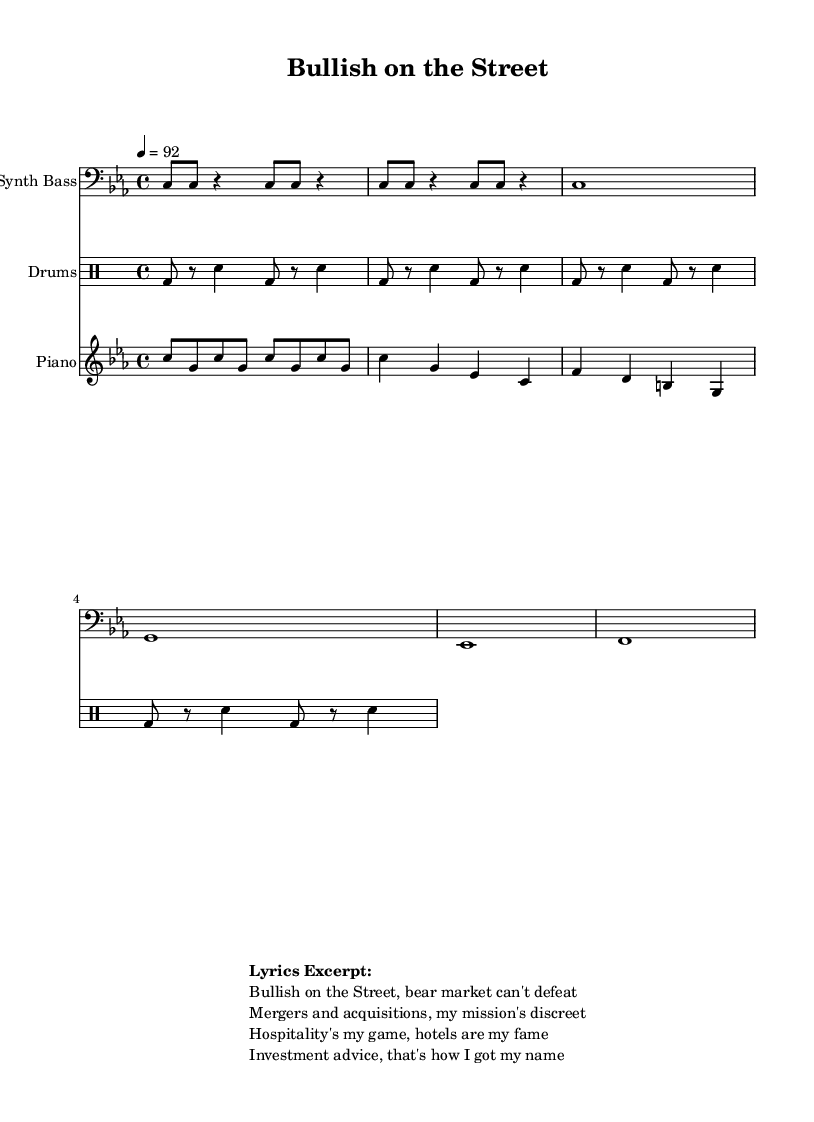What is the key signature of this music? The key signature is C minor, which has three flats: B flat, E flat, and A flat. This is indicated in the music sheet at the beginning of the staff.
Answer: C minor What is the time signature of this music? The time signature is 4/4, which means there are four beats in each measure and a quarter note receives one beat. This is displayed at the start of the score.
Answer: 4/4 What is the tempo of this piece? The tempo is set at 92 beats per minute, indicated by the tempo marking "4 = 92" at the beginning of the score. This tells performers how quickly to play the music.
Answer: 92 How many bars are there in the chorus section? The chorus consists of four bars, which can be counted from the repeated sections in the score. Each group of notes between the vertical lines represents one bar.
Answer: 4 What type of musical styles are represented in this score? The score includes elements typical of rap music with a synth bass, rhythmic drum patterns, and a straightforward piano melody. The overall structure and beats reflect the rap genre's characteristics.
Answer: Rap Which instrument is playing the melody? The melody is being played by the piano, as indicated by the staff labeled with "Piano" at the beginning of that section.
Answer: Piano What is the main theme or focus of the lyrics? The main theme of the lyrics discusses investment banking, specifically highlighting hospitality and strategic advice within the finance industry. This is evident from phrases like "Bullish on the Street" and "Mergers and acquisitions."
Answer: Investment banking 